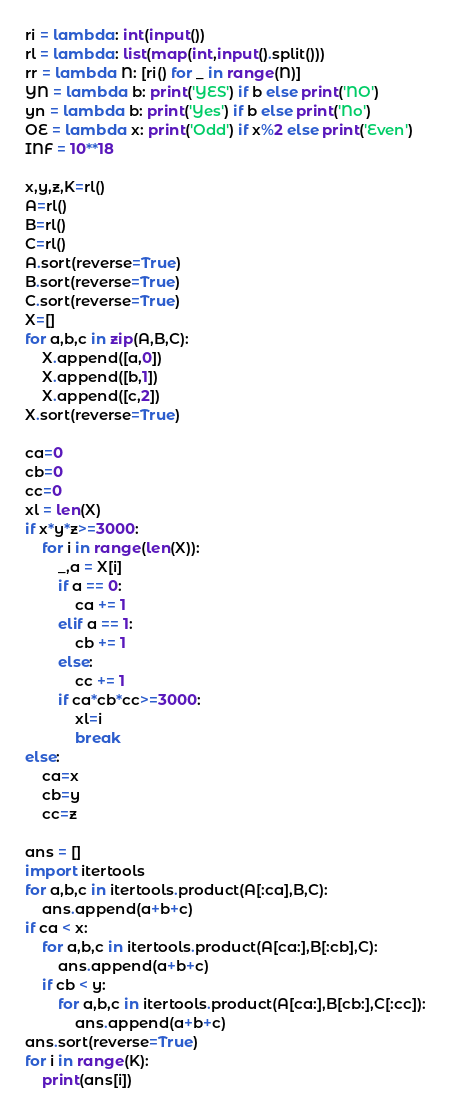Convert code to text. <code><loc_0><loc_0><loc_500><loc_500><_Python_>ri = lambda: int(input())
rl = lambda: list(map(int,input().split()))
rr = lambda N: [ri() for _ in range(N)]
YN = lambda b: print('YES') if b else print('NO')
yn = lambda b: print('Yes') if b else print('No')
OE = lambda x: print('Odd') if x%2 else print('Even')
INF = 10**18

x,y,z,K=rl()
A=rl()
B=rl()
C=rl()
A.sort(reverse=True)
B.sort(reverse=True)
C.sort(reverse=True)
X=[]
for a,b,c in zip(A,B,C):
    X.append([a,0])
    X.append([b,1])
    X.append([c,2])
X.sort(reverse=True)

ca=0
cb=0
cc=0
xl = len(X)
if x*y*z>=3000:
    for i in range(len(X)):
        _,a = X[i]
        if a == 0:
            ca += 1
        elif a == 1:
            cb += 1
        else:
            cc += 1 
        if ca*cb*cc>=3000:
            xl=i
            break
else:
    ca=x
    cb=y
    cc=z

ans = []
import itertools
for a,b,c in itertools.product(A[:ca],B,C):
    ans.append(a+b+c)
if ca < x:
    for a,b,c in itertools.product(A[ca:],B[:cb],C):
        ans.append(a+b+c)
    if cb < y:
        for a,b,c in itertools.product(A[ca:],B[cb:],C[:cc]):
            ans.append(a+b+c)
ans.sort(reverse=True)
for i in range(K):
    print(ans[i])</code> 